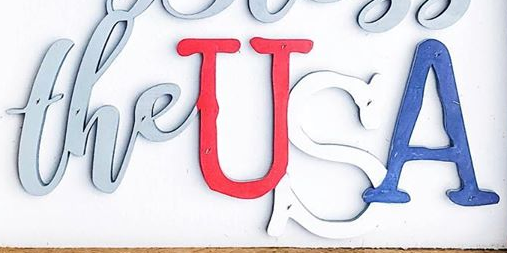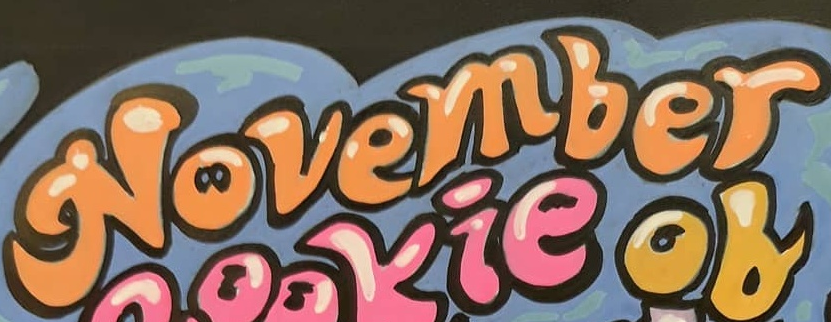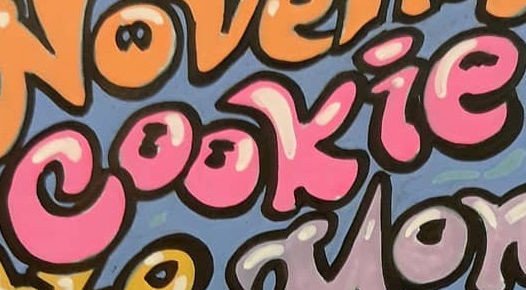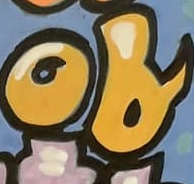Transcribe the words shown in these images in order, separated by a semicolon. theUSA; November; cookie; of 